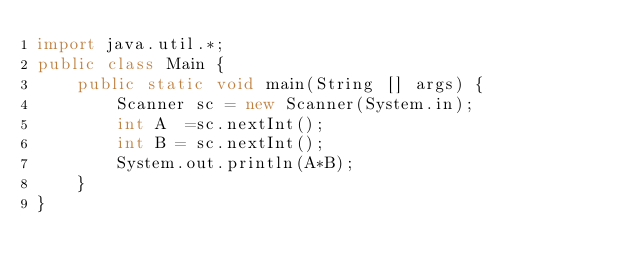<code> <loc_0><loc_0><loc_500><loc_500><_Java_>import java.util.*;
public class Main {
    public static void main(String [] args) {
        Scanner sc = new Scanner(System.in);
        int A  =sc.nextInt();
        int B = sc.nextInt();
        System.out.println(A*B);
    }
}</code> 